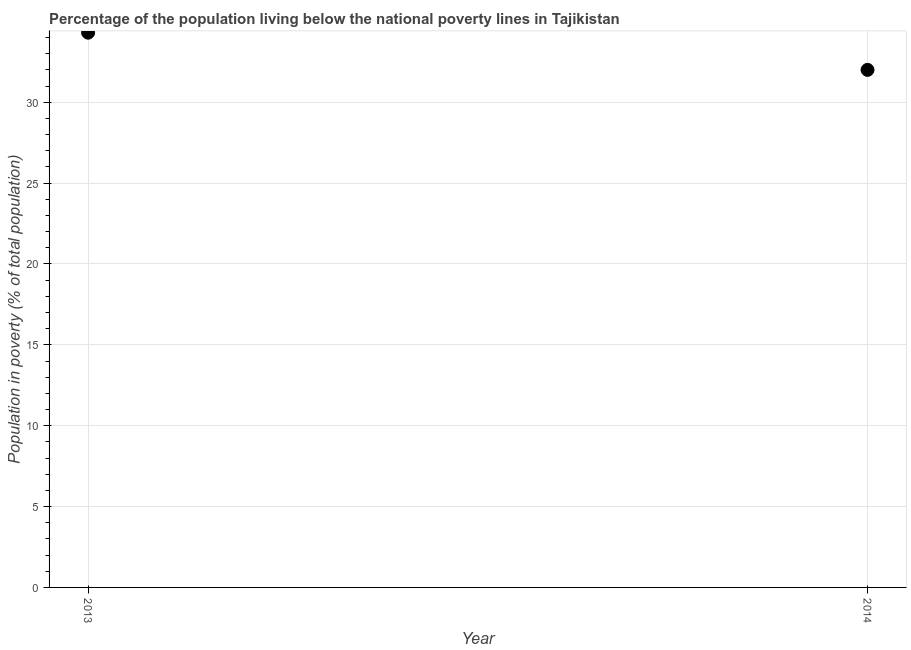Across all years, what is the maximum percentage of population living below poverty line?
Offer a very short reply. 34.3. In which year was the percentage of population living below poverty line maximum?
Your answer should be very brief. 2013. In which year was the percentage of population living below poverty line minimum?
Offer a terse response. 2014. What is the sum of the percentage of population living below poverty line?
Ensure brevity in your answer.  66.3. What is the difference between the percentage of population living below poverty line in 2013 and 2014?
Keep it short and to the point. 2.3. What is the average percentage of population living below poverty line per year?
Provide a short and direct response. 33.15. What is the median percentage of population living below poverty line?
Offer a very short reply. 33.15. In how many years, is the percentage of population living below poverty line greater than 16 %?
Make the answer very short. 2. Do a majority of the years between 2013 and 2014 (inclusive) have percentage of population living below poverty line greater than 29 %?
Give a very brief answer. Yes. What is the ratio of the percentage of population living below poverty line in 2013 to that in 2014?
Provide a succinct answer. 1.07. How many years are there in the graph?
Keep it short and to the point. 2. Does the graph contain any zero values?
Provide a short and direct response. No. Does the graph contain grids?
Give a very brief answer. Yes. What is the title of the graph?
Provide a succinct answer. Percentage of the population living below the national poverty lines in Tajikistan. What is the label or title of the Y-axis?
Your answer should be very brief. Population in poverty (% of total population). What is the Population in poverty (% of total population) in 2013?
Provide a short and direct response. 34.3. What is the ratio of the Population in poverty (% of total population) in 2013 to that in 2014?
Your response must be concise. 1.07. 